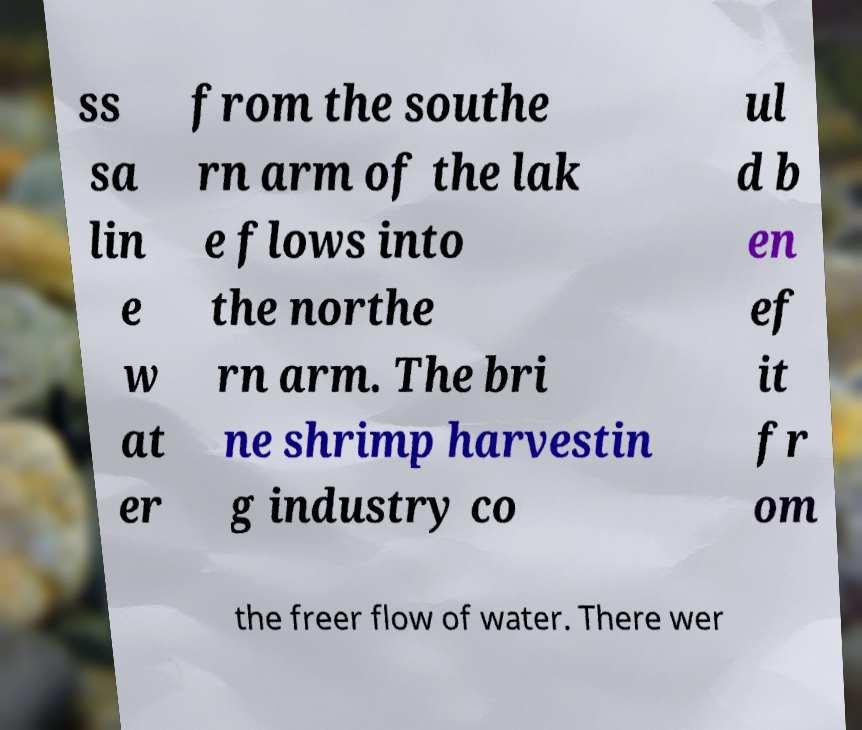Please identify and transcribe the text found in this image. ss sa lin e w at er from the southe rn arm of the lak e flows into the northe rn arm. The bri ne shrimp harvestin g industry co ul d b en ef it fr om the freer flow of water. There wer 